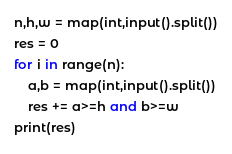Convert code to text. <code><loc_0><loc_0><loc_500><loc_500><_Python_>n,h,w = map(int,input().split())
res = 0
for i in range(n):
    a,b = map(int,input().split())
    res += a>=h and b>=w
print(res)
</code> 